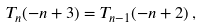<formula> <loc_0><loc_0><loc_500><loc_500>T _ { n } ( - n + 3 ) = T _ { n - 1 } ( - n + 2 ) \, ,</formula> 